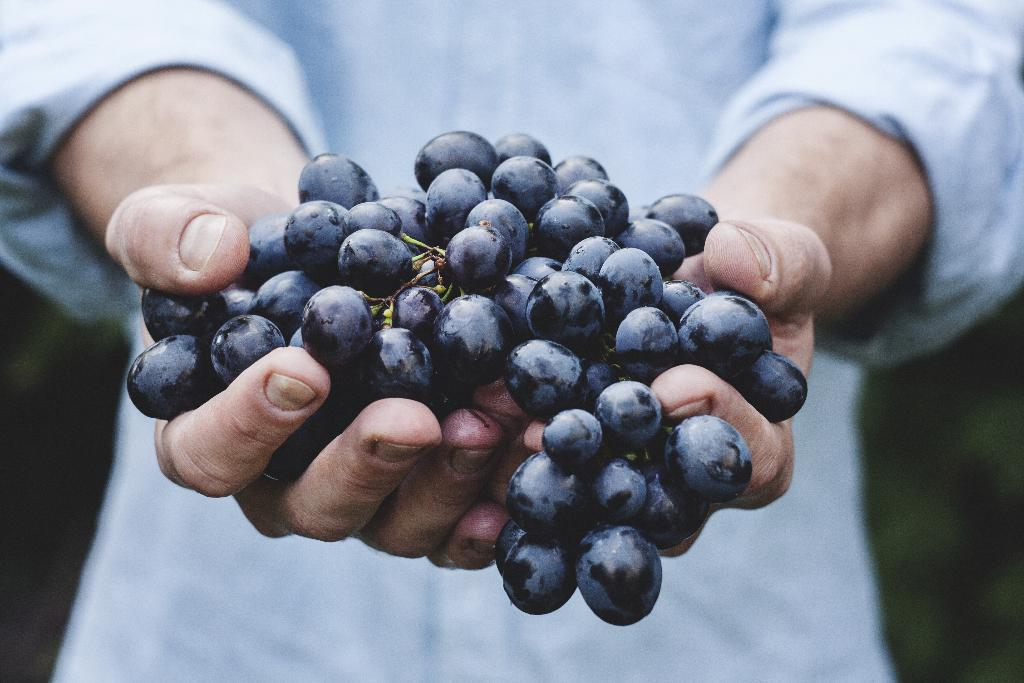Who or what is present in the image? There is a person in the image. What is the person holding in the image? The person is holding a bunch of grapes. What type of kite is the person flying in the image? There is no kite present in the image; the person is holding a bunch of grapes. How many letters are visible in the image? There is no information about letters in the image, as it only features a person holding grapes. 